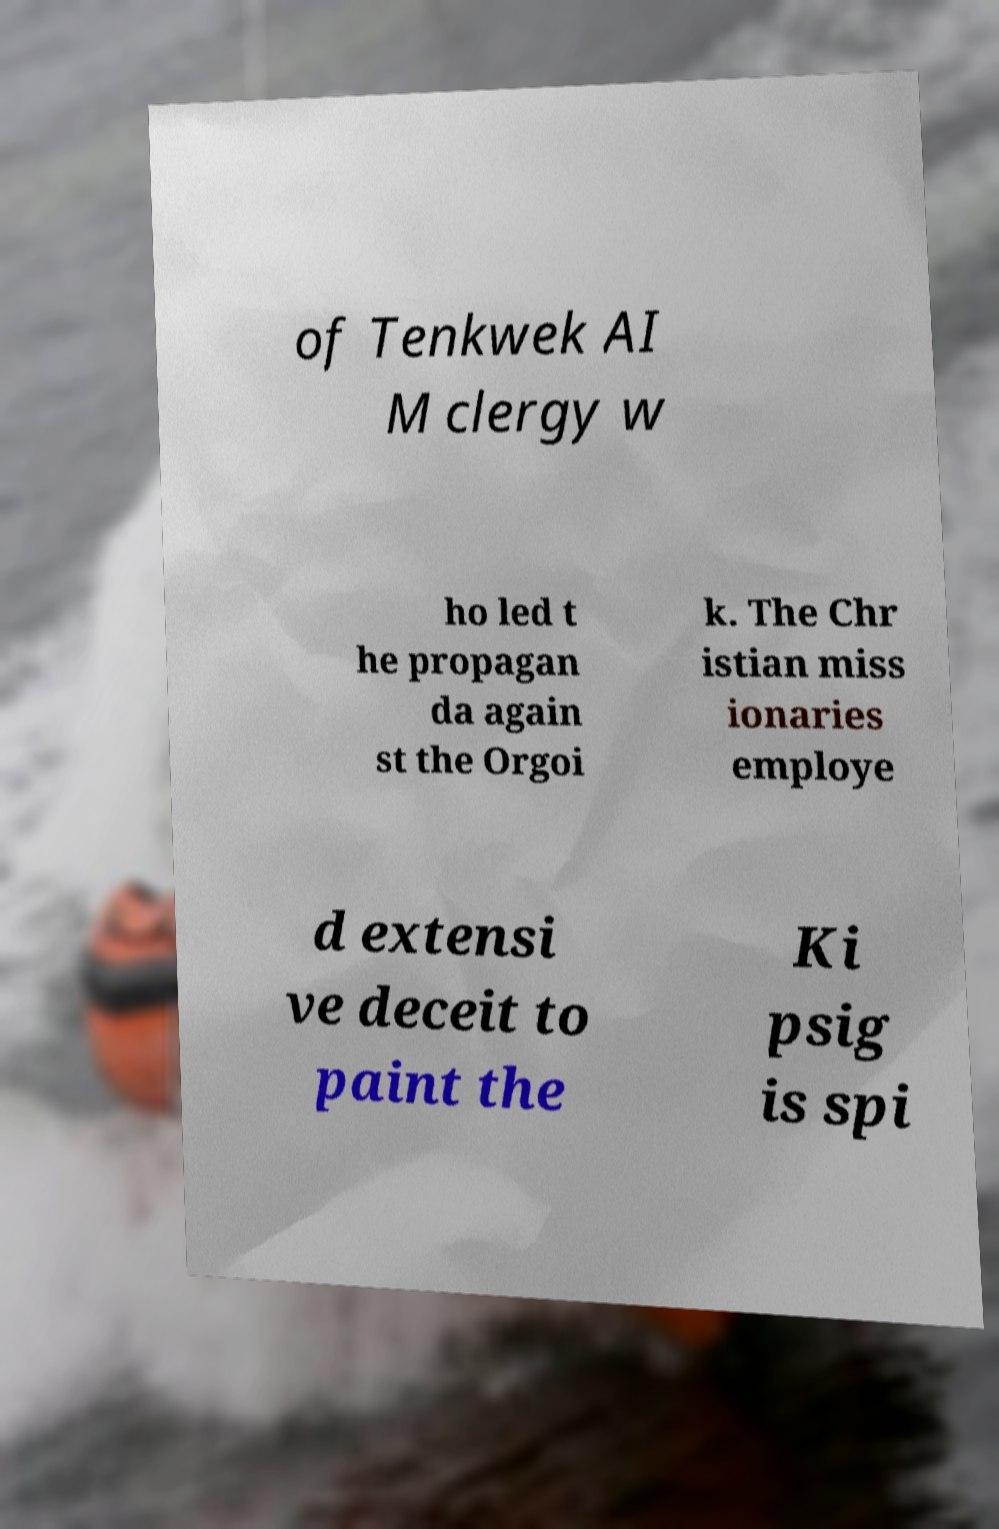For documentation purposes, I need the text within this image transcribed. Could you provide that? of Tenkwek AI M clergy w ho led t he propagan da again st the Orgoi k. The Chr istian miss ionaries employe d extensi ve deceit to paint the Ki psig is spi 